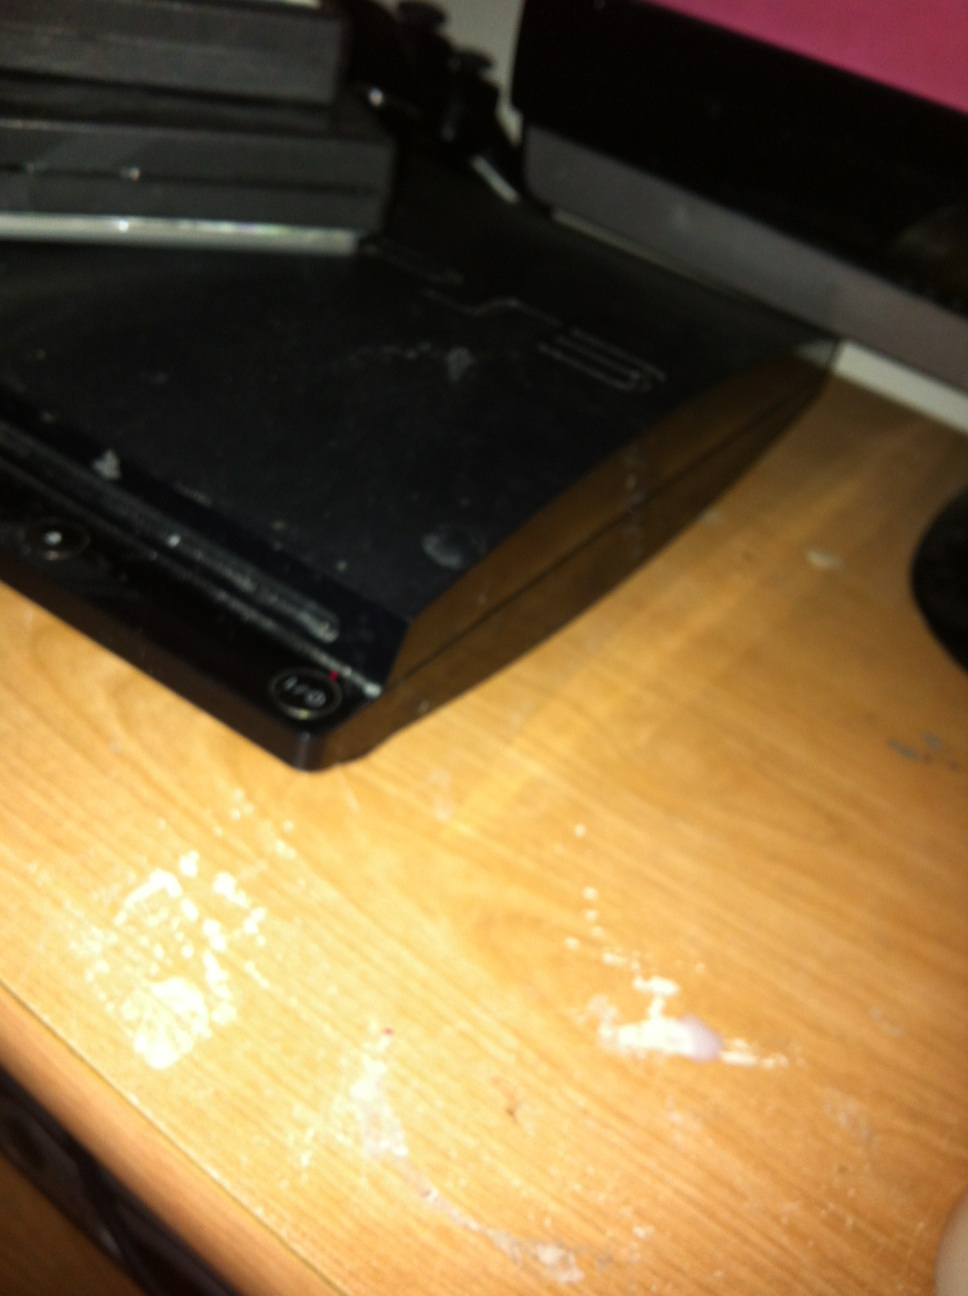Can you tell me more about the PlayStation 3? The PlayStation 3 (PS3) is a home video game console developed by Sony Computer Entertainment. It was first released in November 2006. This model is famous for its powerful hardware for the time, combined with a robust online gaming service, known as the PlayStation Network. The PS3 also introduced the Blu-ray disc format to the PlayStation series. What made the PlayStation 3 stand out in the market? Several features made the PlayStation 3 stand out in the market. Firstly, it was one of the first consoles to use Blu-ray discs, allowing for higher storage capacity and better graphics, which made for richer gaming experiences. Additionally, the PS3 was backward compatible with many PlayStation 2 and PlayStation 1 games, providing a seamless transition for long-time PlayStation fans. The introduction of the PlayStation Network enabled online multiplayer gaming and digital media services. Moreover, the PS3’s powerful Cell microprocessor allowed for advanced graphics and computing capabilities. Can you explain the significance of the PlayStation Network? The PlayStation Network (PSN) is an online gaming and digital media service provided by Sony Interactive Entertainment. Launched in 2006, it significantly expanded the capabilities of the PlayStation 3, offering features such as multiplayer gaming, digital distribution of games, streaming of media content, and access to various services and applications. PSN was crucial in fostering a robust online community and providing a competitive edge against other gaming platforms by allowing users to stay connected, download games, and access a wide variety of multimedia content. 